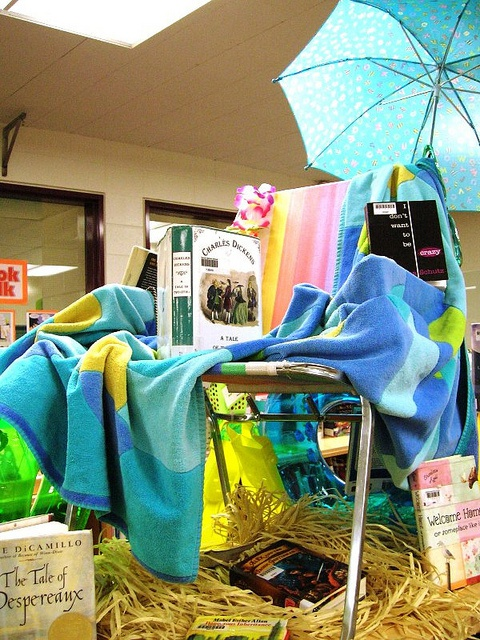Describe the objects in this image and their specific colors. I can see umbrella in white, cyan, lightblue, and teal tones, chair in white, black, olive, ivory, and maroon tones, book in white, tan, and ivory tones, book in white, teal, black, and gray tones, and book in white, beige, khaki, lightpink, and tan tones in this image. 